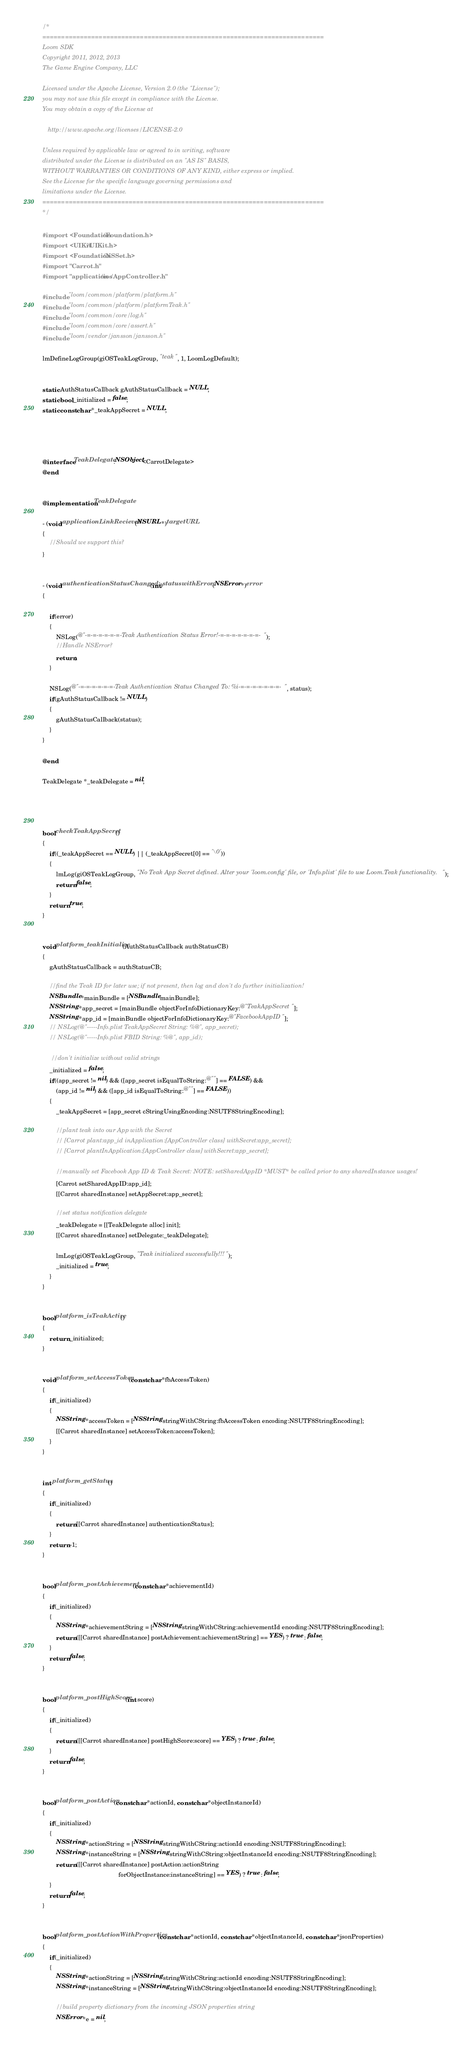<code> <loc_0><loc_0><loc_500><loc_500><_ObjectiveC_>/*
===========================================================================
Loom SDK
Copyright 2011, 2012, 2013 
The Game Engine Company, LLC

Licensed under the Apache License, Version 2.0 (the "License");
you may not use this file except in compliance with the License.
You may obtain a copy of the License at

   http://www.apache.org/licenses/LICENSE-2.0

Unless required by applicable law or agreed to in writing, software
distributed under the License is distributed on an "AS IS" BASIS,
WITHOUT WARRANTIES OR CONDITIONS OF ANY KIND, either express or implied.
See the License for the specific language governing permissions and
limitations under the License. 
===========================================================================
*/

#import <Foundation/Foundation.h>
#import <UIKit/UIKit.h>
#import <Foundation/NSSet.h>
#import "Carrot.h"
#import "application/ios/AppController.h"

#include "loom/common/platform/platform.h"
#include "loom/common/platform/platformTeak.h"
#include "loom/common/core/log.h"
#include "loom/common/core/assert.h"
#include "loom/vendor/jansson/jansson.h"

lmDefineLogGroup(giOSTeakLogGroup, "teak", 1, LoomLogDefault);


static AuthStatusCallback gAuthStatusCallback = NULL;
static bool _initialized = false;
static const char *_teakAppSecret = NULL;




@interface TeakDelegate:NSObject<CarrotDelegate>
@end


@implementation TeakDelegate

- (void)applicationLinkRecieved:(NSURL *)targetURL
{
    //Should we support this?
}


- (void)authenticationStatusChanged:(int)status withError:(NSError *)error
{

    if(error)
    {
        NSLog(@"-=-=-=-=-=-=-Teak Authentication Status Error!-=-=-=-=-=-=-=-");
        //Handle NSError?
        return;
    }

    NSLog(@"-=-=-=-=-=-=-Teak Authentication Status Changed To: %i-=-=-=-=-=-=-=-", status);
    if(gAuthStatusCallback != NULL)
    {
        gAuthStatusCallback(status);
    }
}

@end

TeakDelegate *_teakDelegate = nil;




bool checkTeakAppSecret() 
{
    if((_teakAppSecret == NULL) || (_teakAppSecret[0] == '\0')) 
    {
        lmLog(giOSTeakLogGroup, "No Teak App Secret defined. Alter your 'loom.config' file, or 'Info.plist' file to use Loom.Teak functionality.");
        return false;
    }
    return true;
}


void platform_teakInitialize(AuthStatusCallback authStatusCB)
{
    gAuthStatusCallback = authStatusCB;

    //find the Teak ID for later use; if not present, then log and don't do further initialization!
    NSBundle *mainBundle = [NSBundle mainBundle];
    NSString *app_secret = [mainBundle objectForInfoDictionaryKey:@"TeakAppSecret"];
    NSString *app_id = [mainBundle objectForInfoDictionaryKey:@"FacebookAppID"];
    // NSLog(@"-----Info.plist TeakAppSecret String: %@", app_secret);
    // NSLog(@"-----Info.plist FBID String: %@", app_id);

     //don't initialize without valid strings
    _initialized = false;
    if((app_secret != nil) && ([app_secret isEqualToString:@""] == FALSE) &&
        (app_id != nil) && ([app_id isEqualToString:@""] == FALSE))
    {    
        _teakAppSecret = [app_secret cStringUsingEncoding:NSUTF8StringEncoding];

        //plant teak into our App with the Secret
        // [Carrot plant:app_id inApplication:[AppController class] withSecret:app_secret];
        // [Carrot plantInApplication:[AppController class] withSecret:app_secret];

        //manually set Facebook App ID & Teak Secret: NOTE: setSharedAppID *MUST* be called prior to any sharedInstance usages!
        [Carrot setSharedAppID:app_id];
        [[Carrot sharedInstance] setAppSecret:app_secret];

        //set status notification delegate
        _teakDelegate = [[TeakDelegate alloc] init];
        [[Carrot sharedInstance] setDelegate:_teakDelegate];

        lmLog(giOSTeakLogGroup, "Teak initialized successfully!!!");
        _initialized = true;
    }
}


bool platform_isTeakActive()
{
    return _initialized;
}


void platform_setAccessToken(const char *fbAccessToken)
{
    if(_initialized)
    {
        NSString *accessToken = [NSString stringWithCString:fbAccessToken encoding:NSUTF8StringEncoding];
        [[Carrot sharedInstance] setAccessToken:accessToken];
    }
}


int platform_getStatus()
{
    if(_initialized)
    {
        return [[Carrot sharedInstance] authenticationStatus];
    }
    return -1;
}


bool platform_postAchievement(const char *achievementId)
{
    if(_initialized)
    {
        NSString *achievementString = [NSString stringWithCString:achievementId encoding:NSUTF8StringEncoding];
        return ([[Carrot sharedInstance] postAchievement:achievementString] == YES) ? true : false;
    }
    return false;
}


bool platform_postHighScore(int score)
{
    if(_initialized)
    {
        return ([[Carrot sharedInstance] postHighScore:score] == YES) ? true : false;
    }
    return false;
}


bool platform_postAction(const char *actionId, const char *objectInstanceId)
{
    if(_initialized)
    {
        NSString *actionString = [NSString stringWithCString:actionId encoding:NSUTF8StringEncoding];
        NSString *instanceString = [NSString stringWithCString:objectInstanceId encoding:NSUTF8StringEncoding];
        return ([[Carrot sharedInstance] postAction:actionString
                                            forObjectInstance:instanceString] == YES) ? true : false;
    }
    return false;
}


bool platform_postActionWithProperties(const char *actionId, const char *objectInstanceId, const char *jsonProperties)
{
    if(_initialized)
    {
        NSString *actionString = [NSString stringWithCString:actionId encoding:NSUTF8StringEncoding];
        NSString *instanceString = [NSString stringWithCString:objectInstanceId encoding:NSUTF8StringEncoding];

        //build property dictionary from the incoming JSON properties string
        NSError *e = nil;</code> 